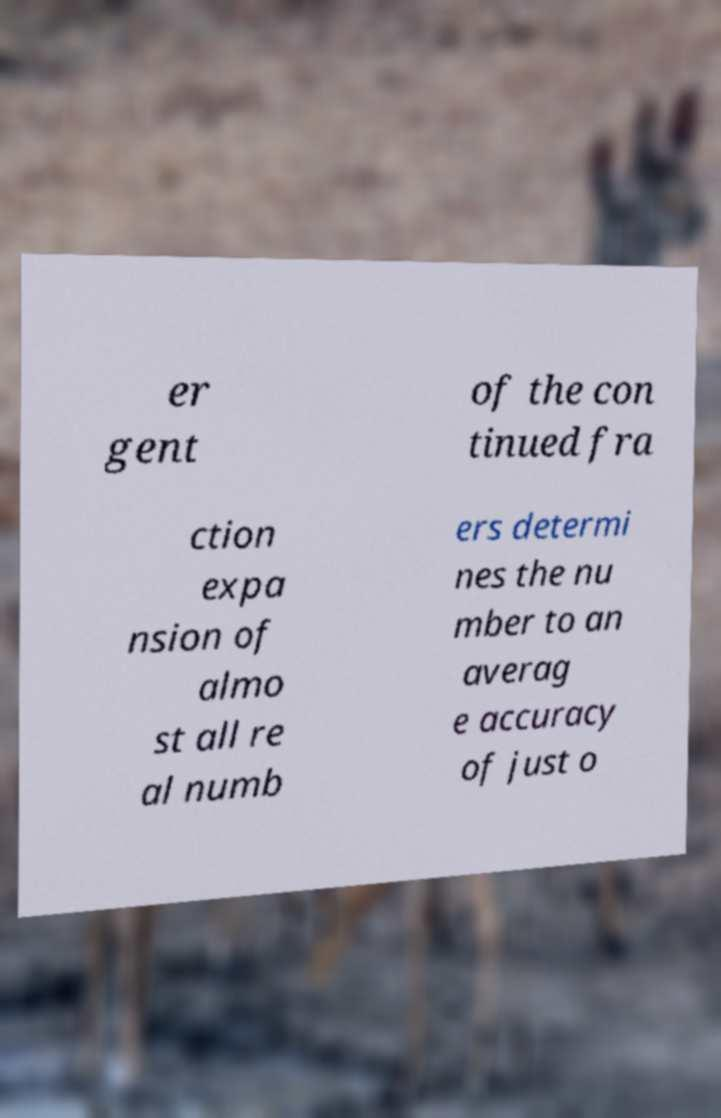Please identify and transcribe the text found in this image. er gent of the con tinued fra ction expa nsion of almo st all re al numb ers determi nes the nu mber to an averag e accuracy of just o 